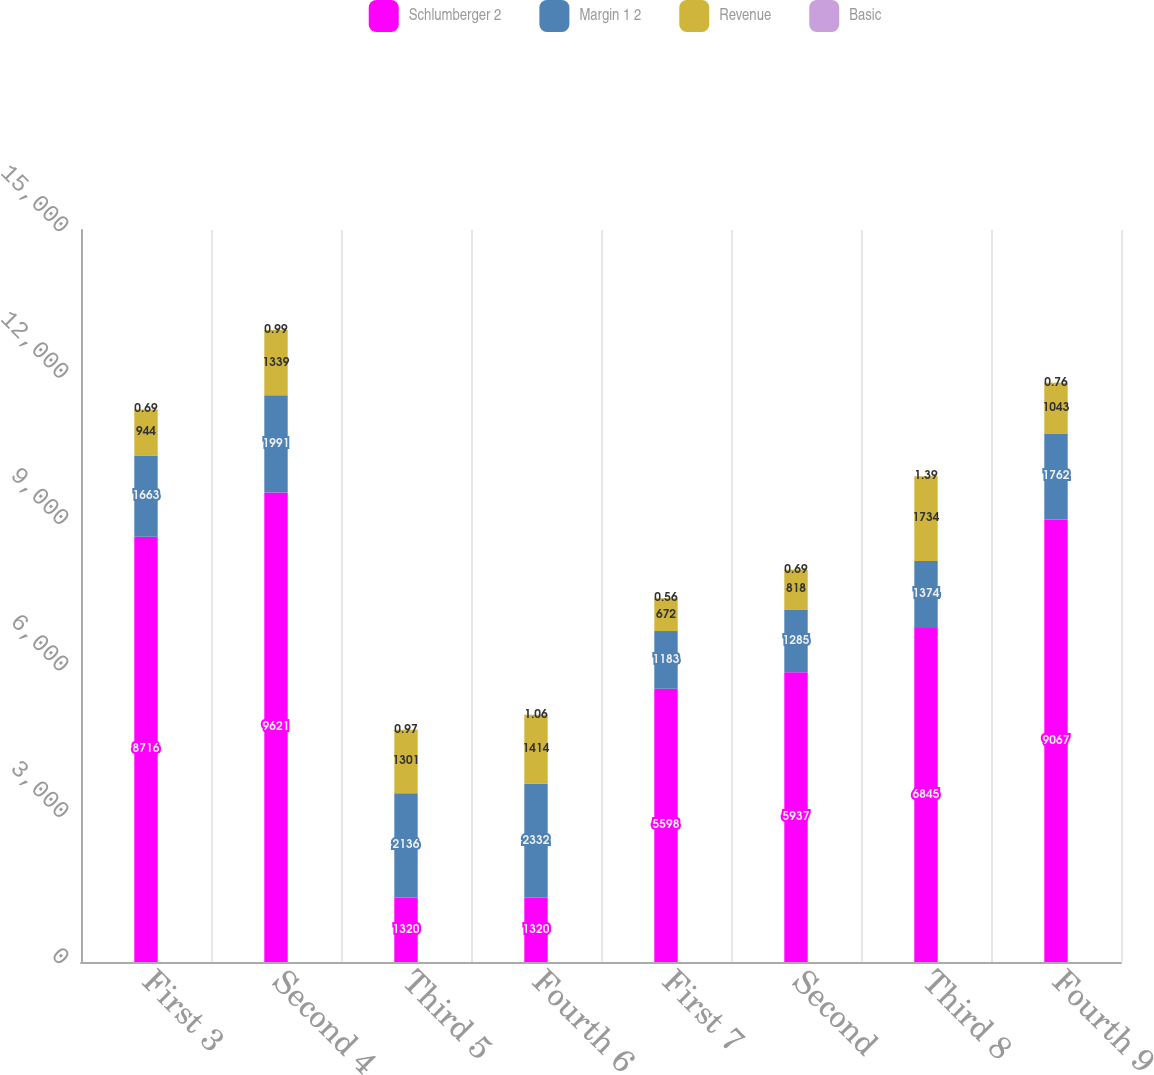Convert chart to OTSL. <chart><loc_0><loc_0><loc_500><loc_500><stacked_bar_chart><ecel><fcel>First 3<fcel>Second 4<fcel>Third 5<fcel>Fourth 6<fcel>First 7<fcel>Second<fcel>Third 8<fcel>Fourth 9<nl><fcel>Schlumberger 2<fcel>8716<fcel>9621<fcel>1320<fcel>1320<fcel>5598<fcel>5937<fcel>6845<fcel>9067<nl><fcel>Margin 1 2<fcel>1663<fcel>1991<fcel>2136<fcel>2332<fcel>1183<fcel>1285<fcel>1374<fcel>1762<nl><fcel>Revenue<fcel>944<fcel>1339<fcel>1301<fcel>1414<fcel>672<fcel>818<fcel>1734<fcel>1043<nl><fcel>Basic<fcel>0.69<fcel>0.99<fcel>0.97<fcel>1.06<fcel>0.56<fcel>0.69<fcel>1.39<fcel>0.76<nl></chart> 